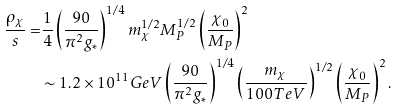<formula> <loc_0><loc_0><loc_500><loc_500>\frac { \rho _ { \chi } } { s } = & \frac { 1 } { 4 } \left ( \frac { 9 0 } { \pi ^ { 2 } g _ { * } } \right ) ^ { 1 / 4 } m _ { \chi } ^ { 1 / 2 } M _ { P } ^ { 1 / 2 } \left ( \frac { \chi _ { 0 } } { M _ { P } } \right ) ^ { 2 } \\ & \sim 1 . 2 \times 1 0 ^ { 1 1 } G e V \left ( \frac { 9 0 } { \pi ^ { 2 } g _ { * } } \right ) ^ { 1 / 4 } \left ( \frac { m _ { \chi } } { 1 0 0 T e V } \right ) ^ { 1 / 2 } \left ( \frac { \chi _ { 0 } } { M _ { P } } \right ) ^ { 2 } .</formula> 